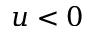Convert formula to latex. <formula><loc_0><loc_0><loc_500><loc_500>u < 0</formula> 